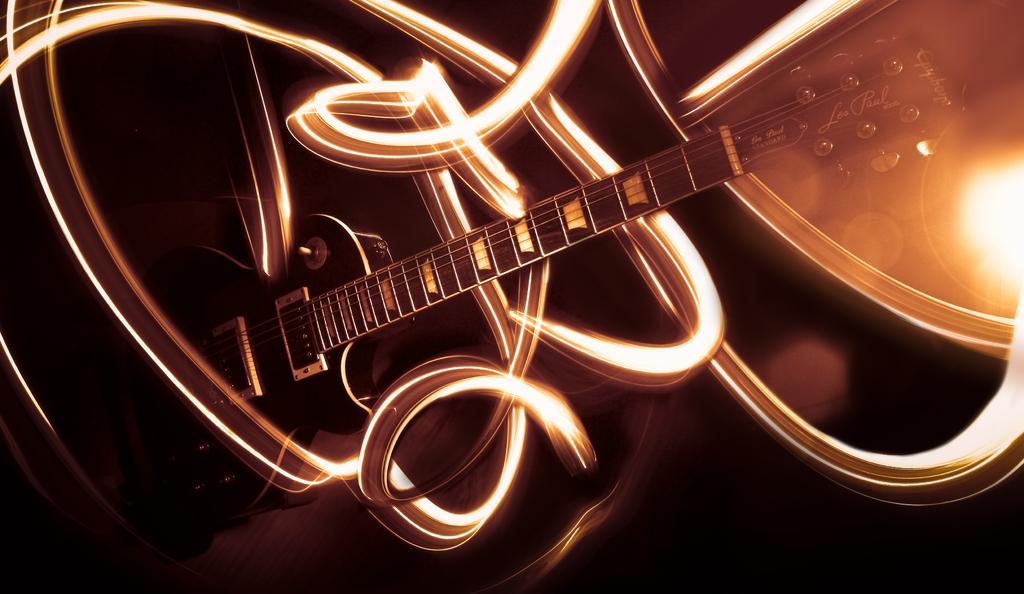What musical instrument is present in the image? There is a guitar in the image. What type of artwork can be seen in the image? There is graffiti in the image. How many times has the guitar been washed in the image? The image does not provide information about the guitar being washed, so we cannot determine the number of times it has been washed. 